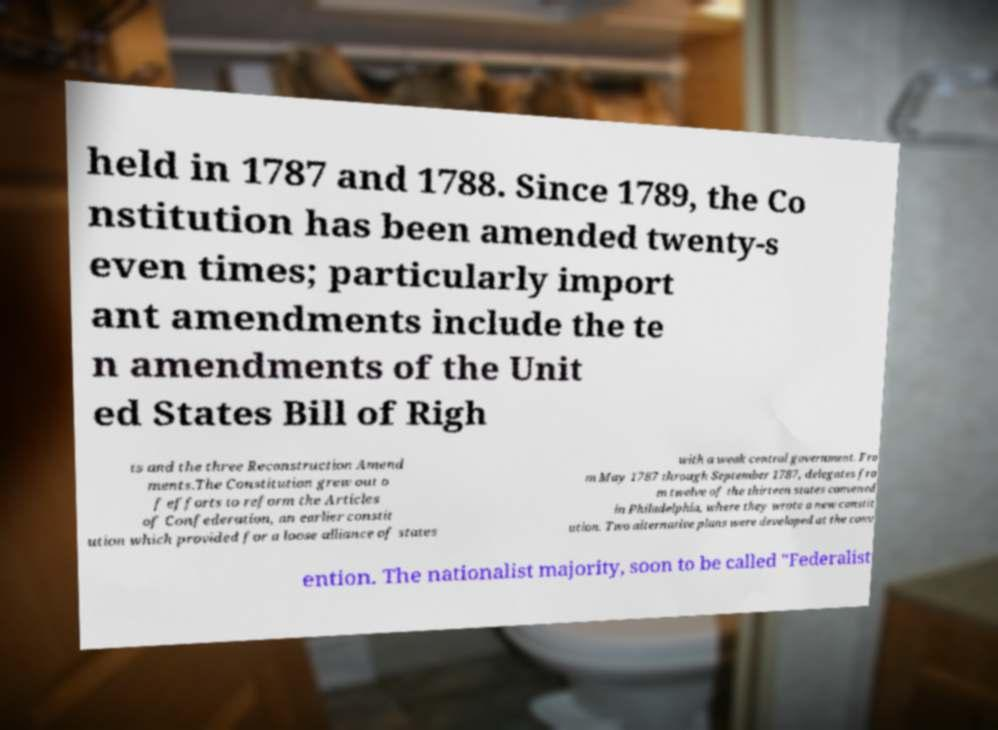What messages or text are displayed in this image? I need them in a readable, typed format. held in 1787 and 1788. Since 1789, the Co nstitution has been amended twenty-s even times; particularly import ant amendments include the te n amendments of the Unit ed States Bill of Righ ts and the three Reconstruction Amend ments.The Constitution grew out o f efforts to reform the Articles of Confederation, an earlier constit ution which provided for a loose alliance of states with a weak central government. Fro m May 1787 through September 1787, delegates fro m twelve of the thirteen states convened in Philadelphia, where they wrote a new constit ution. Two alternative plans were developed at the conv ention. The nationalist majority, soon to be called "Federalist 